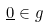<formula> <loc_0><loc_0><loc_500><loc_500>\underline { 0 } \in g</formula> 